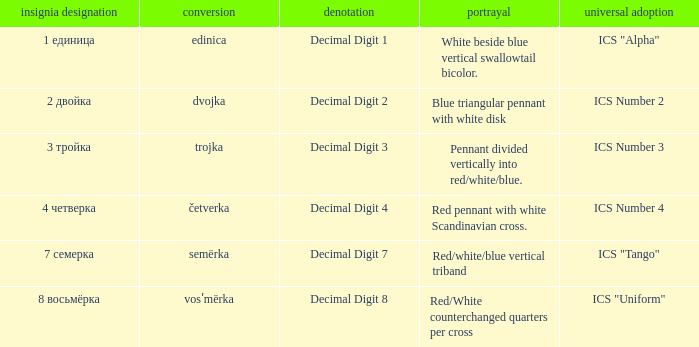What are the meanings of the flag whose name transliterates to semërka? Decimal Digit 7. 